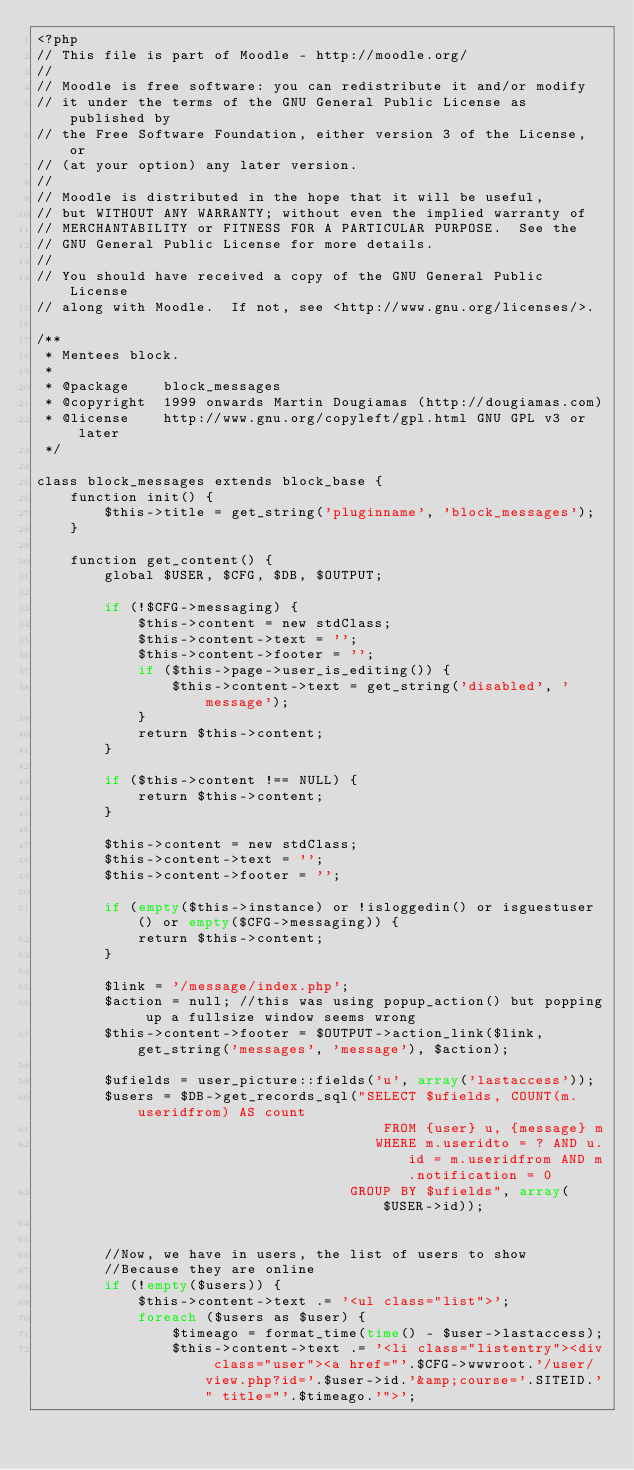<code> <loc_0><loc_0><loc_500><loc_500><_PHP_><?php
// This file is part of Moodle - http://moodle.org/
//
// Moodle is free software: you can redistribute it and/or modify
// it under the terms of the GNU General Public License as published by
// the Free Software Foundation, either version 3 of the License, or
// (at your option) any later version.
//
// Moodle is distributed in the hope that it will be useful,
// but WITHOUT ANY WARRANTY; without even the implied warranty of
// MERCHANTABILITY or FITNESS FOR A PARTICULAR PURPOSE.  See the
// GNU General Public License for more details.
//
// You should have received a copy of the GNU General Public License
// along with Moodle.  If not, see <http://www.gnu.org/licenses/>.

/**
 * Mentees block.
 *
 * @package    block_messages
 * @copyright  1999 onwards Martin Dougiamas (http://dougiamas.com)
 * @license    http://www.gnu.org/copyleft/gpl.html GNU GPL v3 or later
 */

class block_messages extends block_base {
    function init() {
        $this->title = get_string('pluginname', 'block_messages');
    }

    function get_content() {
        global $USER, $CFG, $DB, $OUTPUT;

        if (!$CFG->messaging) {
            $this->content = new stdClass;
            $this->content->text = '';
            $this->content->footer = '';
            if ($this->page->user_is_editing()) {
                $this->content->text = get_string('disabled', 'message');
            }
            return $this->content;
        }

        if ($this->content !== NULL) {
            return $this->content;
        }

        $this->content = new stdClass;
        $this->content->text = '';
        $this->content->footer = '';

        if (empty($this->instance) or !isloggedin() or isguestuser() or empty($CFG->messaging)) {
            return $this->content;
        }

        $link = '/message/index.php';
        $action = null; //this was using popup_action() but popping up a fullsize window seems wrong
        $this->content->footer = $OUTPUT->action_link($link, get_string('messages', 'message'), $action);

        $ufields = user_picture::fields('u', array('lastaccess'));
        $users = $DB->get_records_sql("SELECT $ufields, COUNT(m.useridfrom) AS count
                                         FROM {user} u, {message} m
                                        WHERE m.useridto = ? AND u.id = m.useridfrom AND m.notification = 0
                                     GROUP BY $ufields", array($USER->id));


        //Now, we have in users, the list of users to show
        //Because they are online
        if (!empty($users)) {
            $this->content->text .= '<ul class="list">';
            foreach ($users as $user) {
                $timeago = format_time(time() - $user->lastaccess);
                $this->content->text .= '<li class="listentry"><div class="user"><a href="'.$CFG->wwwroot.'/user/view.php?id='.$user->id.'&amp;course='.SITEID.'" title="'.$timeago.'">';</code> 